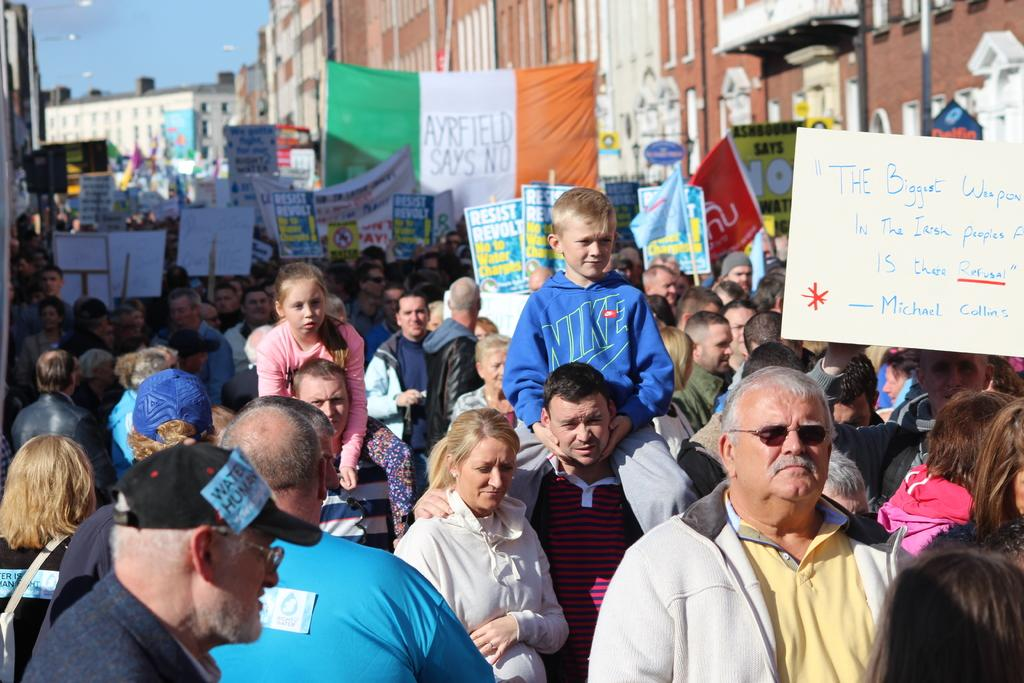Who or what can be seen in the image? There are people in the image. What are some of the people holding? Some people are holding boards. What can be found on the boards? There is there any information or message? What can be seen in the distance behind the people? There are buildings in the background of the image. How many minutes does it take for the curve to be completed in the image? There is no curve present in the image, so it is not possible to determine how long it would take to complete it. 